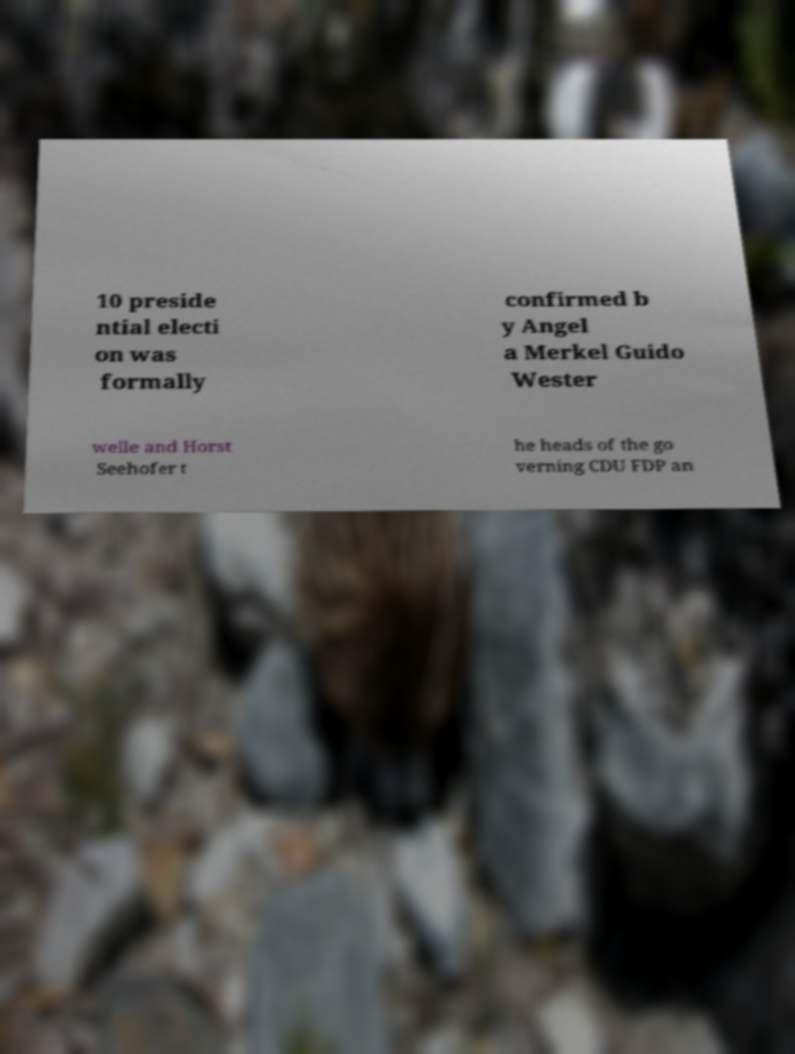For documentation purposes, I need the text within this image transcribed. Could you provide that? 10 preside ntial electi on was formally confirmed b y Angel a Merkel Guido Wester welle and Horst Seehofer t he heads of the go verning CDU FDP an 